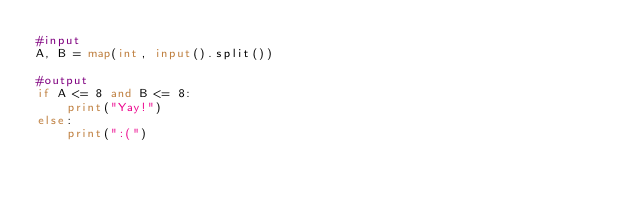Convert code to text. <code><loc_0><loc_0><loc_500><loc_500><_Python_>#input
A, B = map(int, input().split())

#output
if A <= 8 and B <= 8:
    print("Yay!")
else:
    print(":(")
    </code> 